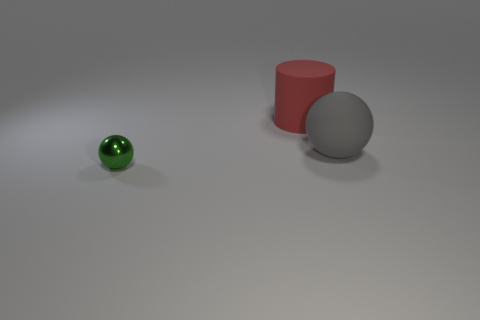There is a large rubber object that is behind the ball right of the tiny green object; what number of small shiny balls are on the left side of it?
Your answer should be compact. 1. What material is the sphere on the right side of the small green metallic thing in front of the big matte object that is in front of the red rubber cylinder made of?
Your answer should be compact. Rubber. Is the large object that is on the right side of the big red thing made of the same material as the tiny green thing?
Your answer should be very brief. No. How many gray rubber spheres are the same size as the red matte cylinder?
Provide a succinct answer. 1. Are there more spheres that are behind the green metal sphere than large red things that are in front of the big red object?
Your answer should be very brief. Yes. Are there any gray matte objects that have the same shape as the small green metallic thing?
Make the answer very short. Yes. How big is the thing in front of the big matte object that is in front of the red matte cylinder?
Your answer should be very brief. Small. There is a big matte object that is behind the sphere right of the sphere left of the cylinder; what is its shape?
Make the answer very short. Cylinder. The red cylinder that is made of the same material as the gray sphere is what size?
Your response must be concise. Large. Is the number of large gray rubber things greater than the number of small red matte cylinders?
Your answer should be very brief. Yes. 